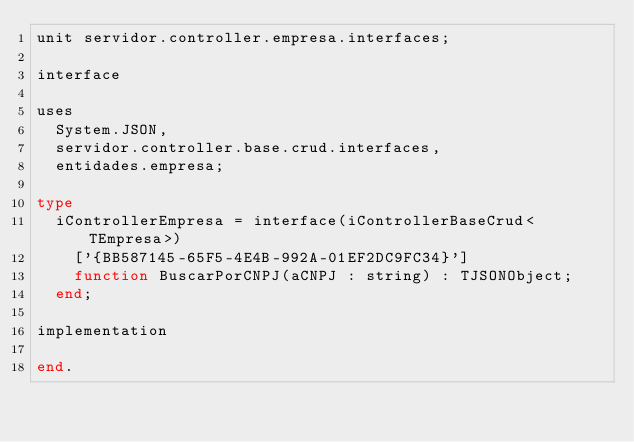Convert code to text. <code><loc_0><loc_0><loc_500><loc_500><_Pascal_>unit servidor.controller.empresa.interfaces;

interface

uses
  System.JSON,
  servidor.controller.base.crud.interfaces,
  entidades.empresa;

type
  iControllerEmpresa = interface(iControllerBaseCrud<TEmpresa>)
    ['{BB587145-65F5-4E4B-992A-01EF2DC9FC34}']
    function BuscarPorCNPJ(aCNPJ : string) : TJSONObject;
  end;

implementation

end.
</code> 